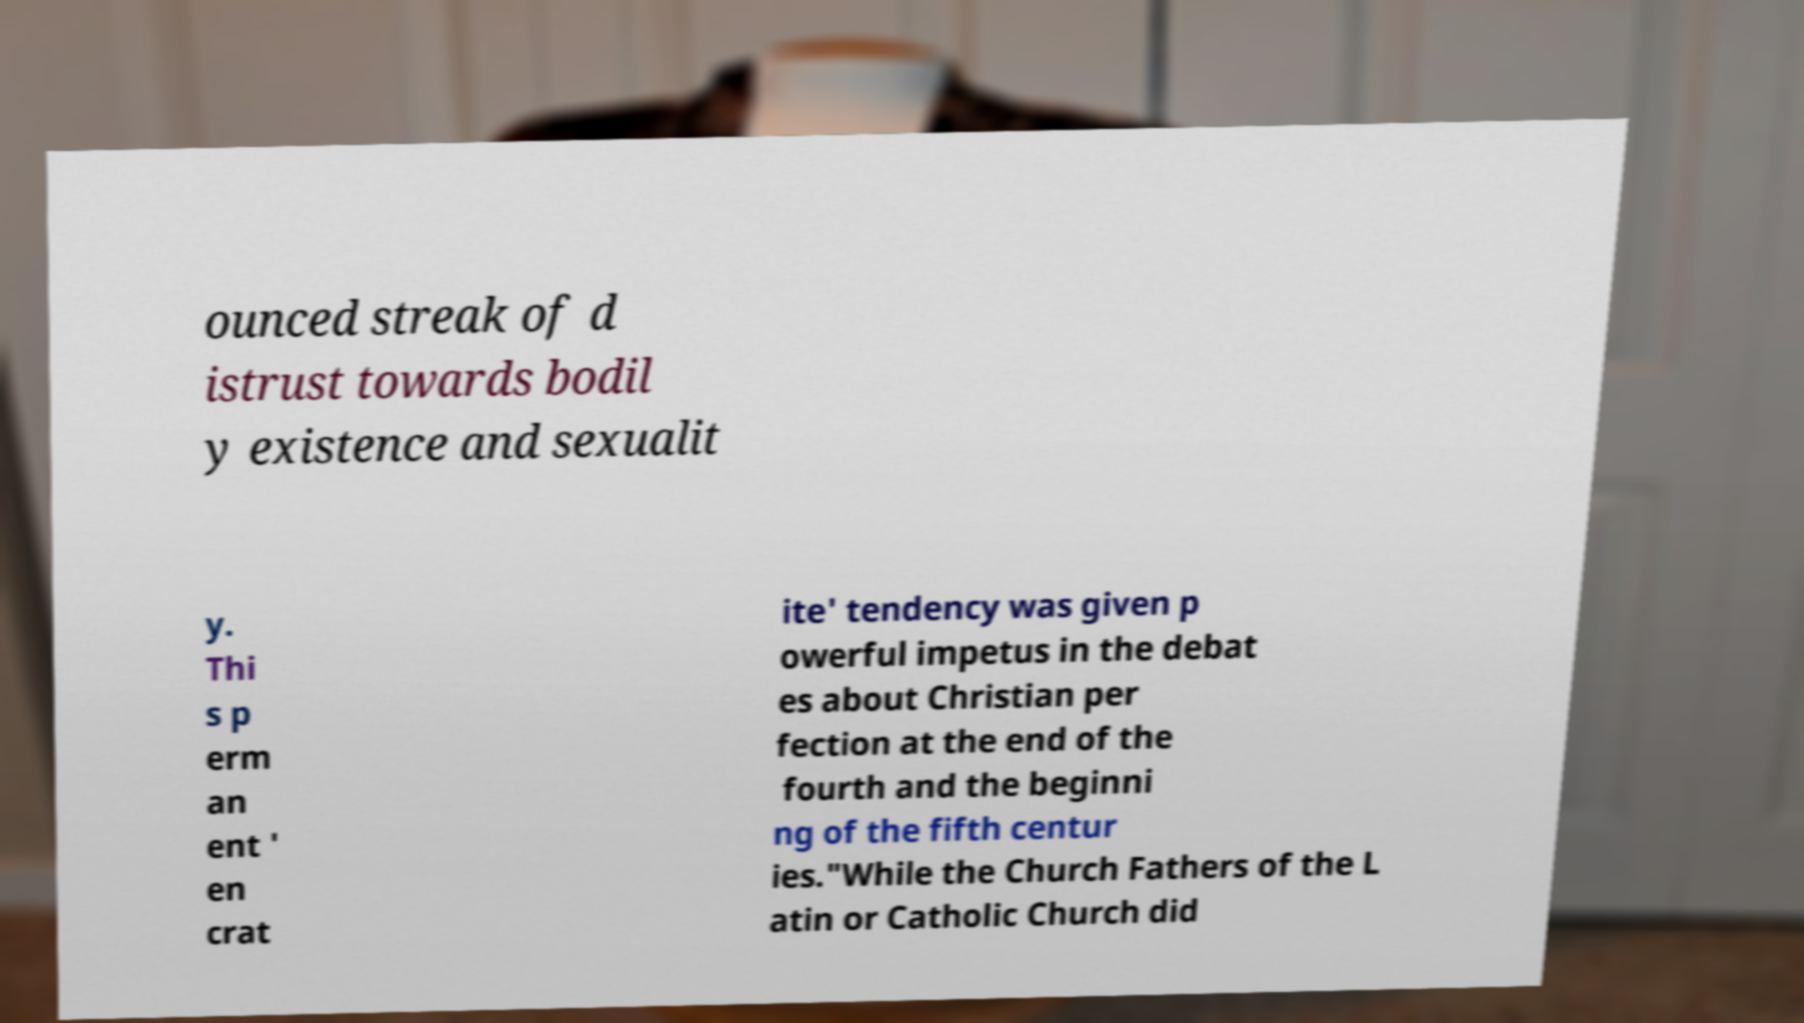I need the written content from this picture converted into text. Can you do that? ounced streak of d istrust towards bodil y existence and sexualit y. Thi s p erm an ent ' en crat ite' tendency was given p owerful impetus in the debat es about Christian per fection at the end of the fourth and the beginni ng of the fifth centur ies."While the Church Fathers of the L atin or Catholic Church did 